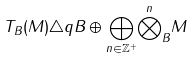Convert formula to latex. <formula><loc_0><loc_0><loc_500><loc_500>T _ { B } ( M ) \triangle q B \oplus \underset { n \in \mathbb { Z } ^ { + } } { \bigoplus } { \overset { n } { \bigotimes } _ { B } } M</formula> 